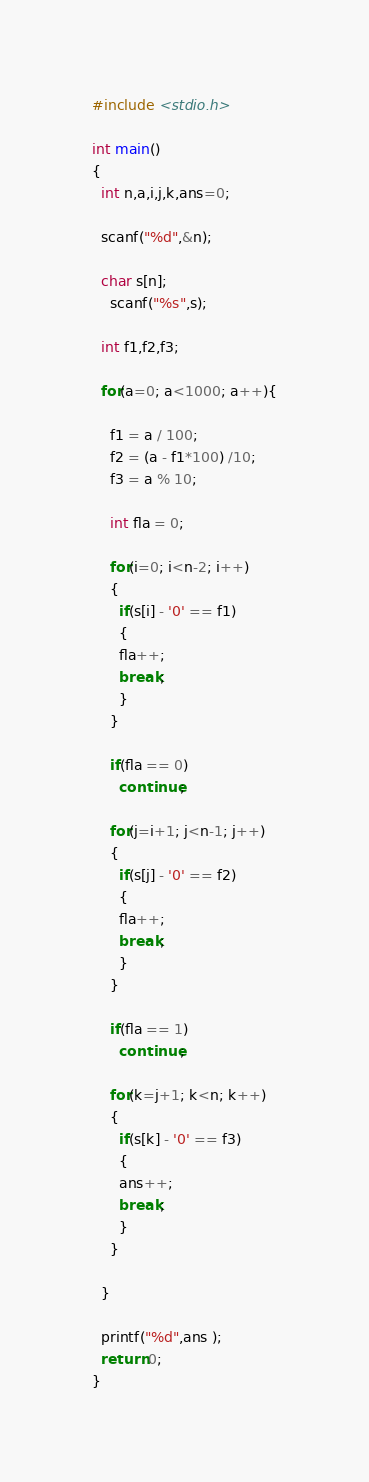Convert code to text. <code><loc_0><loc_0><loc_500><loc_500><_C_>#include <stdio.h>

int main()
{
  int n,a,i,j,k,ans=0;

  scanf("%d",&n);

  char s[n];
    scanf("%s",s);

  int f1,f2,f3;

  for(a=0; a<1000; a++){

    f1 = a / 100;
    f2 = (a - f1*100) /10;
    f3 = a % 10;

    int fla = 0;

    for(i=0; i<n-2; i++)
    {
      if(s[i] - '0' == f1)
      {
      fla++;
      break;
      }
    }

    if(fla == 0)
      continue;

    for(j=i+1; j<n-1; j++)
    {
      if(s[j] - '0' == f2)
      {
      fla++;
      break;
      }
    }

    if(fla == 1)
      continue;

    for(k=j+1; k<n; k++)
    {
      if(s[k] - '0' == f3)
      {
      ans++;
      break;
      }
    }

  }

  printf("%d",ans );
  return 0;
}
</code> 